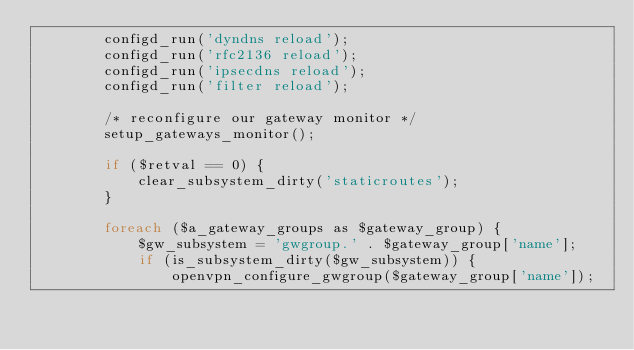Convert code to text. <code><loc_0><loc_0><loc_500><loc_500><_PHP_>        configd_run('dyndns reload');
        configd_run('rfc2136 reload');
        configd_run('ipsecdns reload');
        configd_run('filter reload');

        /* reconfigure our gateway monitor */
        setup_gateways_monitor();

        if ($retval == 0) {
            clear_subsystem_dirty('staticroutes');
        }

        foreach ($a_gateway_groups as $gateway_group) {
            $gw_subsystem = 'gwgroup.' . $gateway_group['name'];
            if (is_subsystem_dirty($gw_subsystem)) {
                openvpn_configure_gwgroup($gateway_group['name']);</code> 